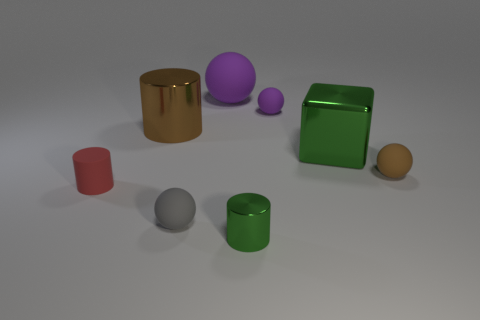If these objects were part of a game, which one would be the most valuable and why? If these objects were part of a game, the gold cylinder might be the most valuable due to its color commonly representing wealth and rarity. Its unique sheen and standout appearance compared to the other objects may signify a higher in-game status or value. 